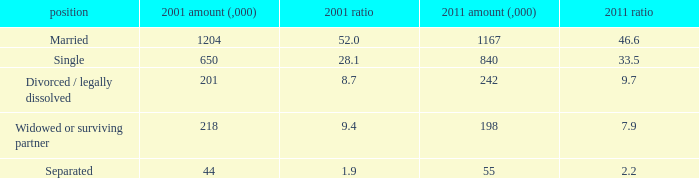How many 2011 % is 7.9? 1.0. 